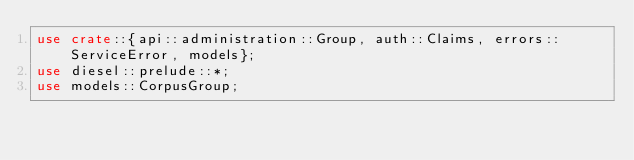Convert code to text. <code><loc_0><loc_0><loc_500><loc_500><_Rust_>use crate::{api::administration::Group, auth::Claims, errors::ServiceError, models};
use diesel::prelude::*;
use models::CorpusGroup;</code> 